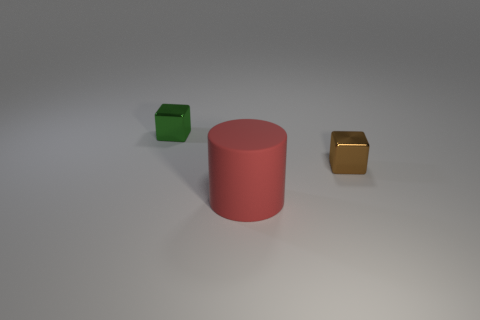How would you describe the lighting in this scene? The lighting in the scene is soft and diffuse, illuminating the objects from above. It casts gentle shadows directly beneath the objects, indicating that the light source is positioned overhead. The overall effect creates a calm and clean atmosphere. 